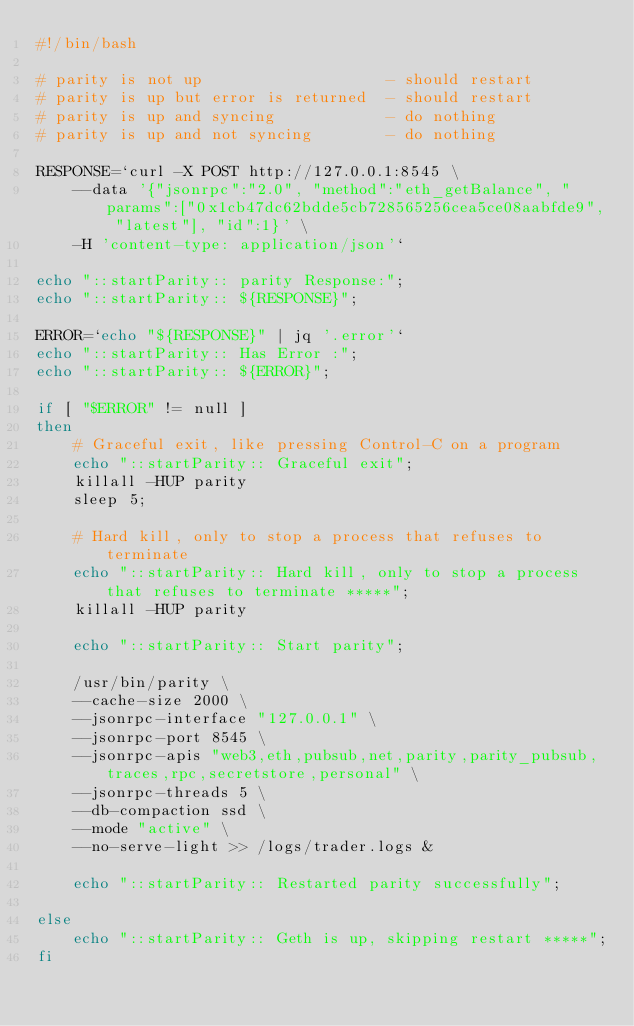Convert code to text. <code><loc_0><loc_0><loc_500><loc_500><_Bash_>#!/bin/bash

# parity is not up                    - should restart
# parity is up but error is returned  - should restart
# parity is up and syncing            - do nothing
# parity is up and not syncing        - do nothing

RESPONSE=`curl -X POST http://127.0.0.1:8545 \
    --data '{"jsonrpc":"2.0", "method":"eth_getBalance", "params":["0x1cb47dc62bdde5cb728565256cea5ce08aabfde9", "latest"], "id":1}' \
    -H 'content-type: application/json'`

echo "::startParity:: parity Response:";
echo "::startParity:: ${RESPONSE}";

ERROR=`echo "${RESPONSE}" | jq '.error'`
echo "::startParity:: Has Error :";
echo "::startParity:: ${ERROR}";

if [ "$ERROR" != null ]
then
    # Graceful exit, like pressing Control-C on a program
    echo "::startParity:: Graceful exit";
    killall -HUP parity
    sleep 5;

    # Hard kill, only to stop a process that refuses to terminate
    echo "::startParity:: Hard kill, only to stop a process that refuses to terminate *****";
    killall -HUP parity

    echo "::startParity:: Start parity";
    
    /usr/bin/parity \
    --cache-size 2000 \
    --jsonrpc-interface "127.0.0.1" \
    --jsonrpc-port 8545 \
    --jsonrpc-apis "web3,eth,pubsub,net,parity,parity_pubsub,traces,rpc,secretstore,personal" \
    --jsonrpc-threads 5 \
    --db-compaction ssd \
    --mode "active" \
    --no-serve-light >> /logs/trader.logs &

    echo "::startParity:: Restarted parity successfully";

else
    echo "::startParity:: Geth is up, skipping restart *****";
fi
</code> 